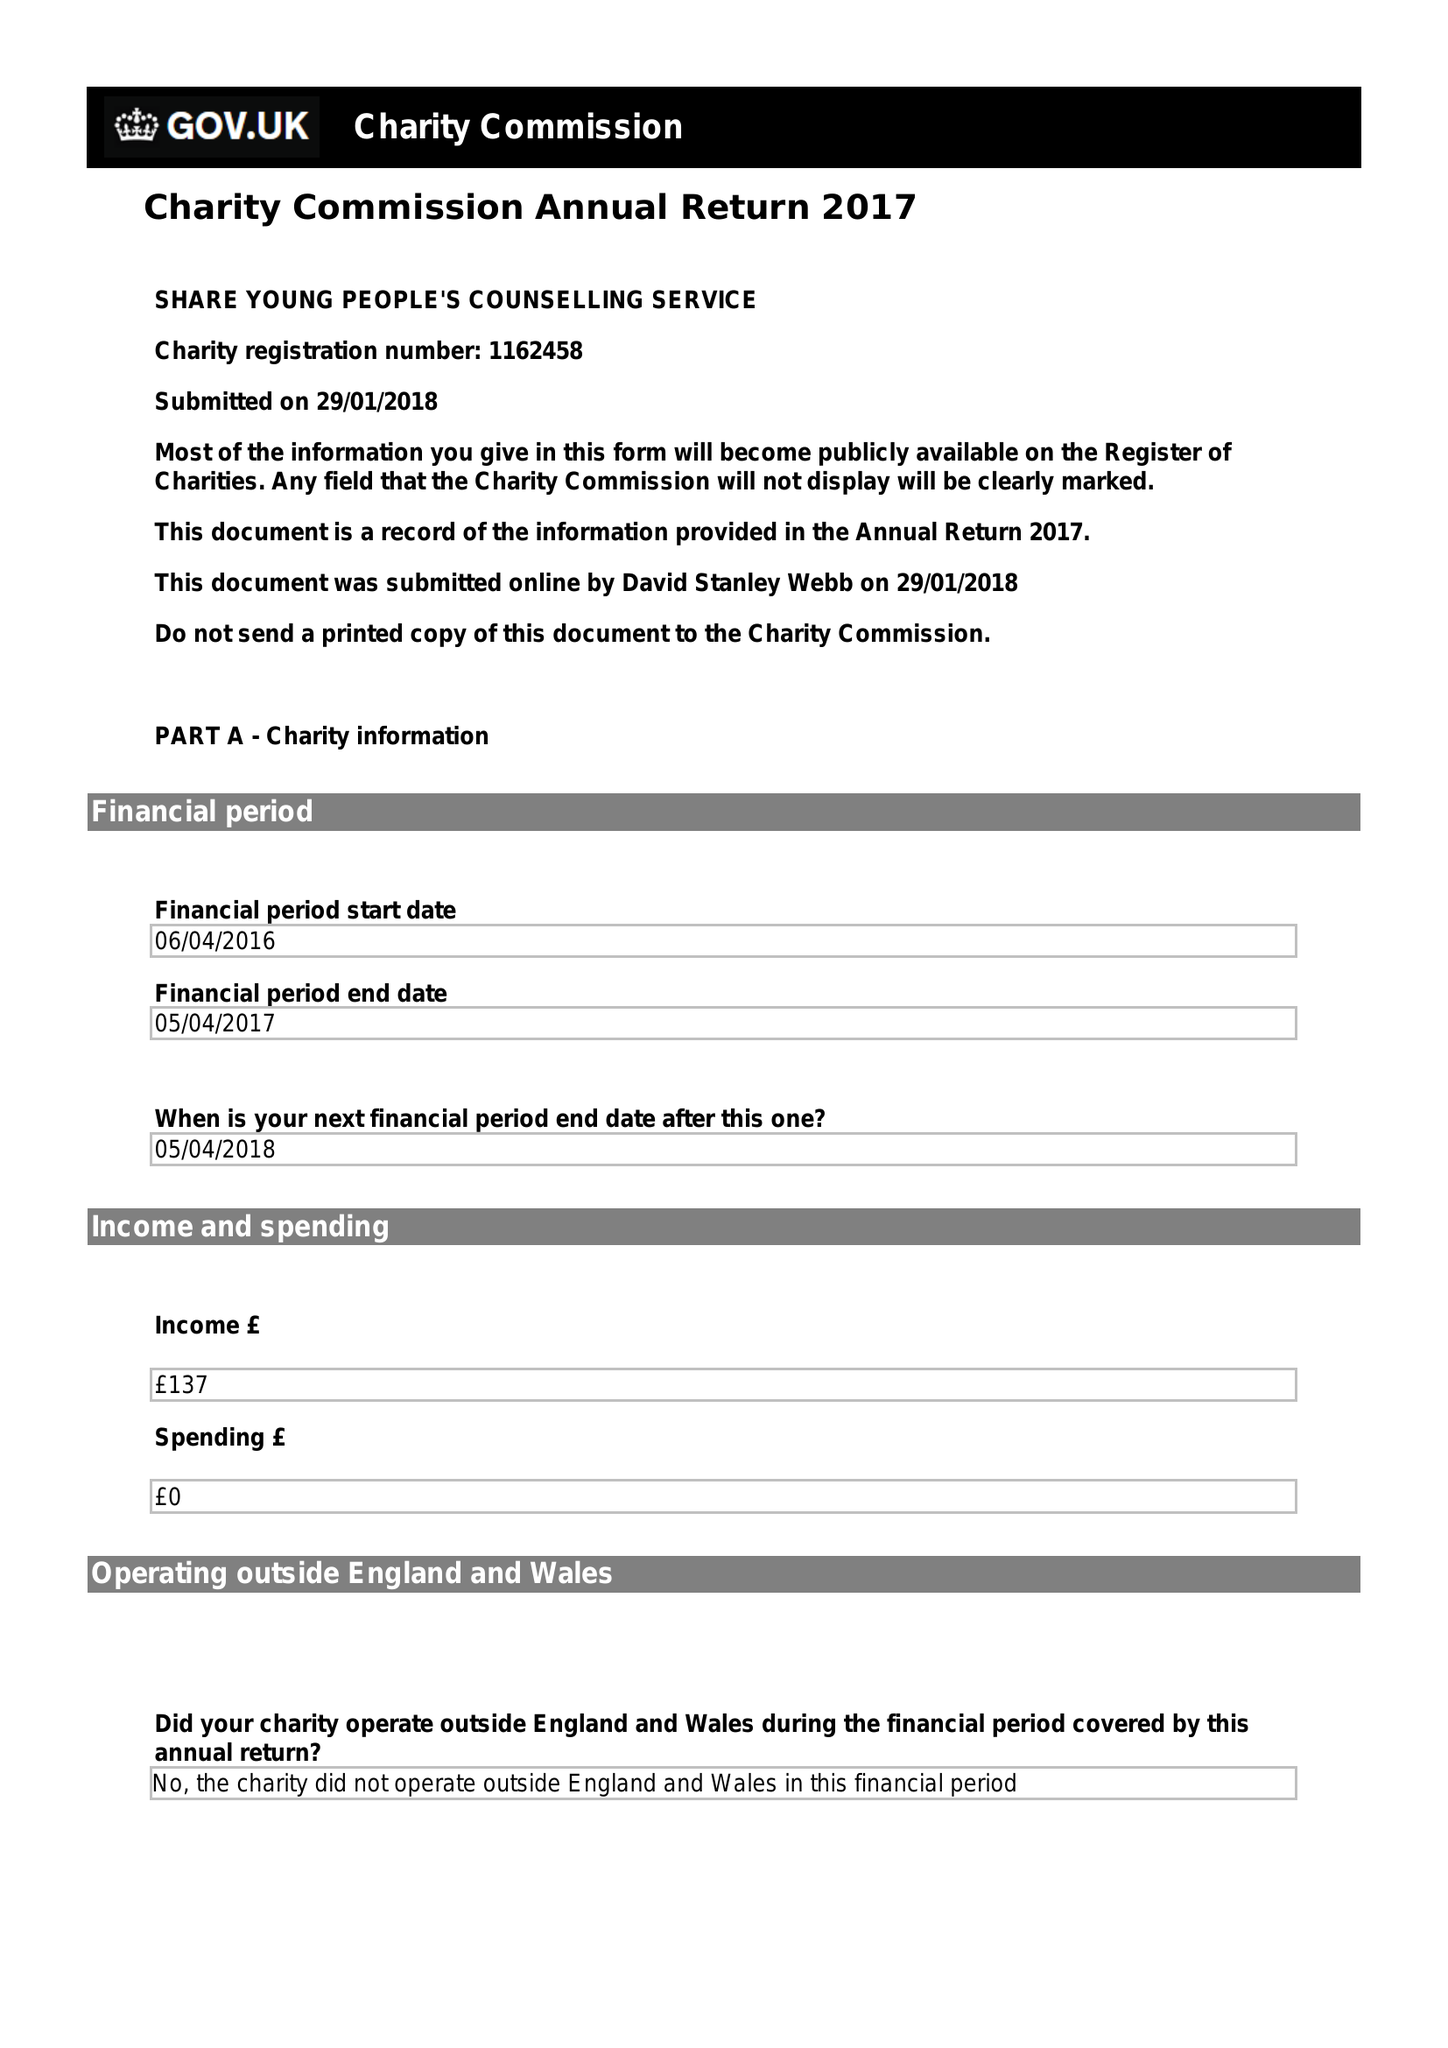What is the value for the address__post_town?
Answer the question using a single word or phrase. CHELTENHAM 